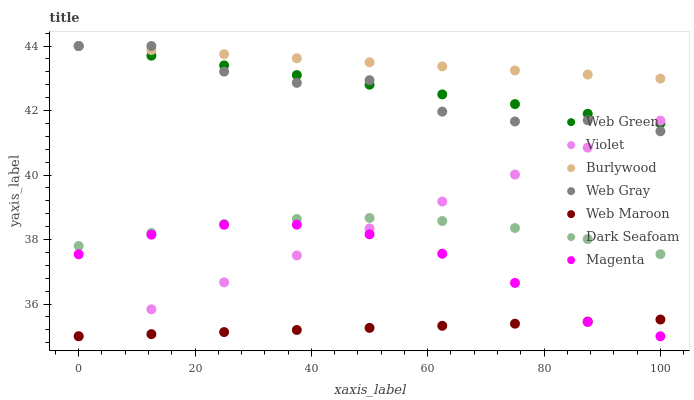Does Web Maroon have the minimum area under the curve?
Answer yes or no. Yes. Does Burlywood have the maximum area under the curve?
Answer yes or no. Yes. Does Burlywood have the minimum area under the curve?
Answer yes or no. No. Does Web Maroon have the maximum area under the curve?
Answer yes or no. No. Is Web Maroon the smoothest?
Answer yes or no. Yes. Is Web Gray the roughest?
Answer yes or no. Yes. Is Burlywood the smoothest?
Answer yes or no. No. Is Burlywood the roughest?
Answer yes or no. No. Does Web Maroon have the lowest value?
Answer yes or no. Yes. Does Burlywood have the lowest value?
Answer yes or no. No. Does Web Green have the highest value?
Answer yes or no. Yes. Does Web Maroon have the highest value?
Answer yes or no. No. Is Dark Seafoam less than Web Gray?
Answer yes or no. Yes. Is Web Green greater than Magenta?
Answer yes or no. Yes. Does Magenta intersect Violet?
Answer yes or no. Yes. Is Magenta less than Violet?
Answer yes or no. No. Is Magenta greater than Violet?
Answer yes or no. No. Does Dark Seafoam intersect Web Gray?
Answer yes or no. No. 